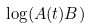Convert formula to latex. <formula><loc_0><loc_0><loc_500><loc_500>\log ( A ( t ) B )</formula> 